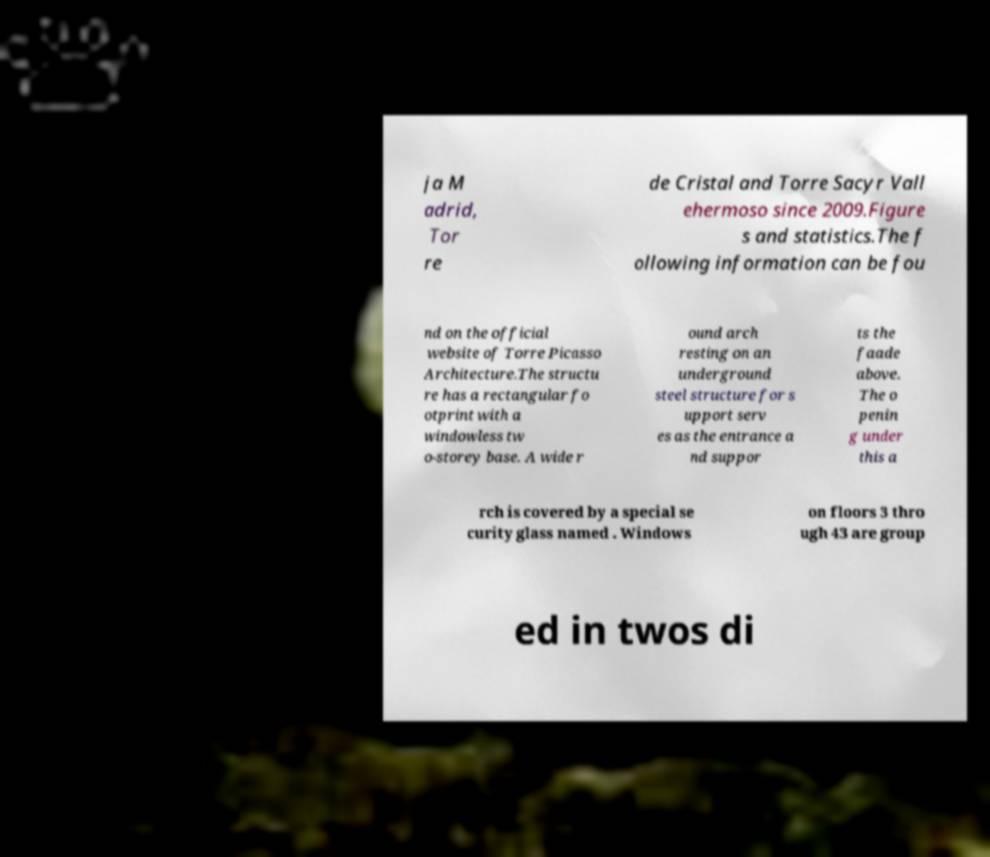For documentation purposes, I need the text within this image transcribed. Could you provide that? ja M adrid, Tor re de Cristal and Torre Sacyr Vall ehermoso since 2009.Figure s and statistics.The f ollowing information can be fou nd on the official website of Torre Picasso Architecture.The structu re has a rectangular fo otprint with a windowless tw o-storey base. A wide r ound arch resting on an underground steel structure for s upport serv es as the entrance a nd suppor ts the faade above. The o penin g under this a rch is covered by a special se curity glass named . Windows on floors 3 thro ugh 43 are group ed in twos di 